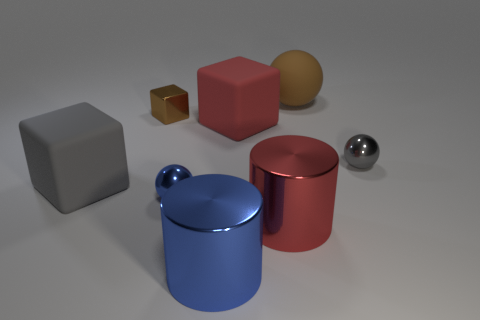What number of other objects are there of the same material as the small gray ball?
Ensure brevity in your answer.  4. The big rubber block right of the metallic sphere that is in front of the tiny ball behind the large gray cube is what color?
Your response must be concise. Red. There is a brown thing that is to the right of the sphere on the left side of the large red cube; what is its shape?
Your answer should be very brief. Sphere. Is the number of red metal things that are in front of the small brown block greater than the number of tiny blue shiny cylinders?
Make the answer very short. Yes. There is a large red object that is in front of the large red rubber cube; is its shape the same as the small brown object?
Keep it short and to the point. No. Is there a red rubber object of the same shape as the gray rubber thing?
Your response must be concise. Yes. How many things are small metallic objects that are left of the big brown matte sphere or brown metal cylinders?
Provide a short and direct response. 2. Are there more large purple cylinders than red rubber cubes?
Provide a succinct answer. No. Is there a red cube of the same size as the red metallic thing?
Offer a terse response. Yes. How many things are either things that are behind the brown metal cube or rubber things that are in front of the tiny cube?
Your response must be concise. 3. 